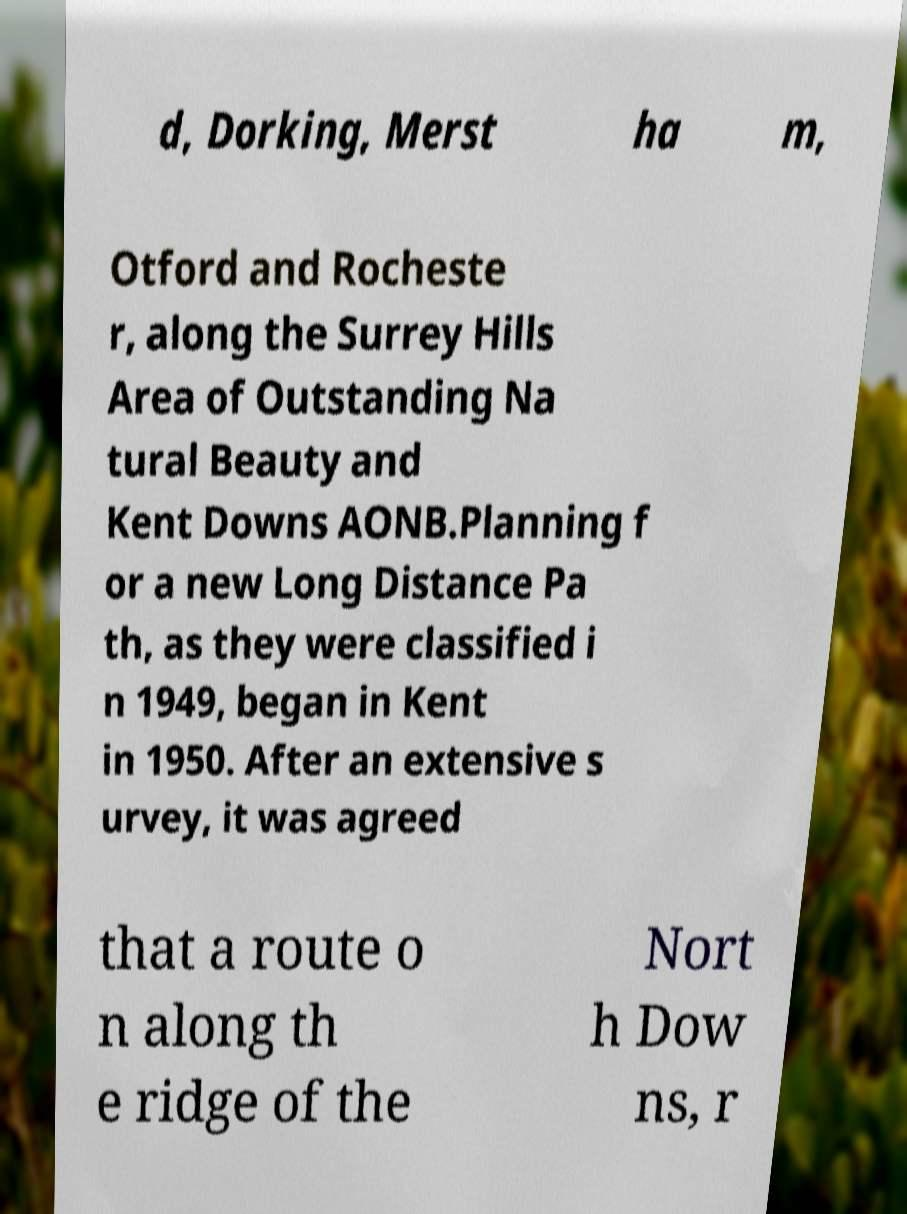I need the written content from this picture converted into text. Can you do that? d, Dorking, Merst ha m, Otford and Rocheste r, along the Surrey Hills Area of Outstanding Na tural Beauty and Kent Downs AONB.Planning f or a new Long Distance Pa th, as they were classified i n 1949, began in Kent in 1950. After an extensive s urvey, it was agreed that a route o n along th e ridge of the Nort h Dow ns, r 